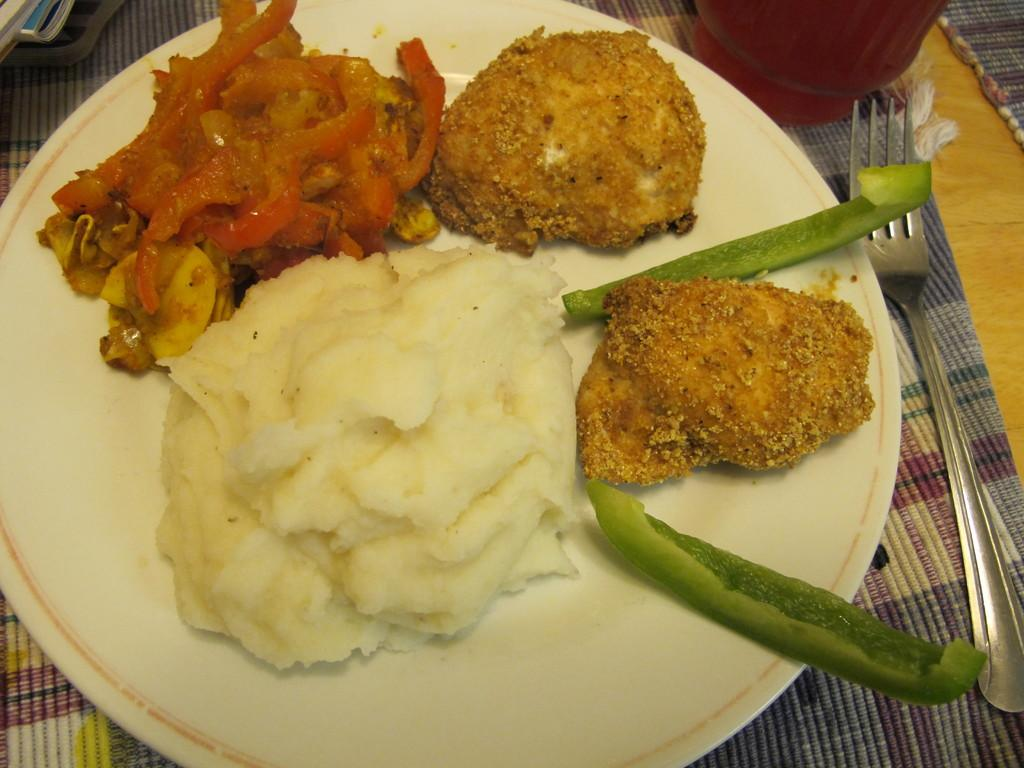What piece of furniture is present in the image? There is a table in the image. What is placed on the table? There is a plate and a fork on the table. What can be inferred about the purpose of the table? The presence of a plate and a fork suggests that the table is being used for dining. What else might be on the table besides the plate and fork? There are food items on the table. What color are the eyes of the person eating the food in the image? There is no person present in the image, so it is not possible to determine the color of their eyes. 